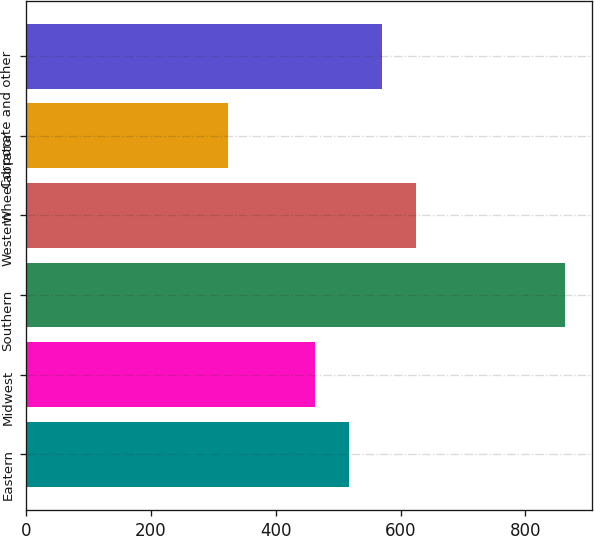Convert chart. <chart><loc_0><loc_0><loc_500><loc_500><bar_chart><fcel>Eastern<fcel>Midwest<fcel>Southern<fcel>Western<fcel>Wheelabrator<fcel>Corporate and other<nl><fcel>517<fcel>463<fcel>863<fcel>625<fcel>323<fcel>571<nl></chart> 